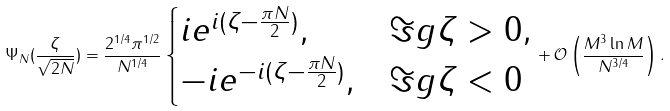Convert formula to latex. <formula><loc_0><loc_0><loc_500><loc_500>\Psi _ { N } ( \frac { \zeta } { \sqrt { 2 N } } ) = \frac { 2 ^ { 1 / 4 } \pi ^ { 1 / 2 } } { N ^ { 1 / 4 } } \begin{cases} i e ^ { i ( \zeta - \frac { \pi N } { 2 } ) } , & \Im g \zeta > 0 , \\ - i e ^ { - i ( \zeta - \frac { \pi N } { 2 } ) } , & \Im g \zeta < 0 \end{cases} + \mathcal { O } \left ( \frac { M ^ { 3 } \ln M } { N ^ { 3 / 4 } } \right ) .</formula> 